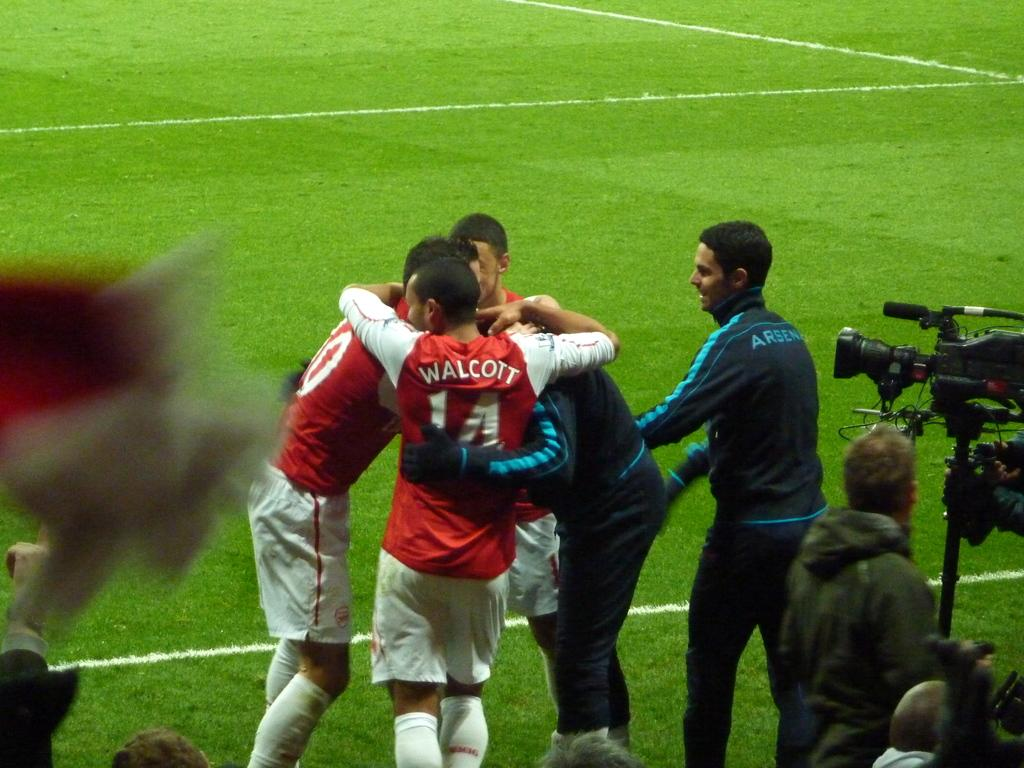How many people are in the image? There is a group of people in the image, but the exact number is not specified. What is the surface the people are standing on? The people are standing on grass in the image. What equipment is visible in the image? There is a camera stand in the image. What can be inferred about the weather during the time the image was taken? The image was likely taken during a sunny day, as indicated by the facts. Where was the image taken? The image was taken on a field. What smell is associated with the people in the image? There is no information about smells in the image, so it cannot be determined. What are the people in the image afraid of? There is no indication of fear or any specific emotion in the image, so it cannot be determined. 